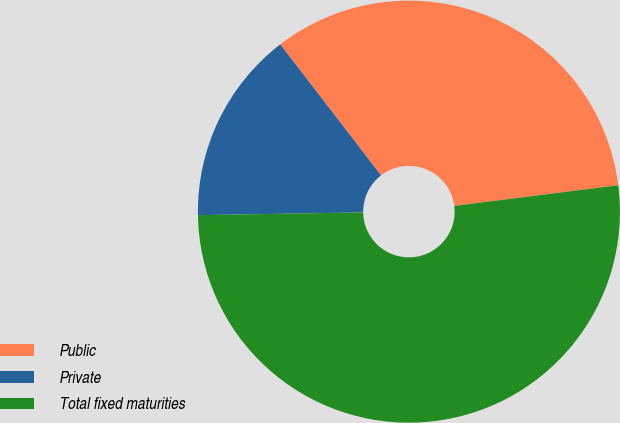Convert chart. <chart><loc_0><loc_0><loc_500><loc_500><pie_chart><fcel>Public<fcel>Private<fcel>Total fixed maturities<nl><fcel>33.44%<fcel>14.83%<fcel>51.73%<nl></chart> 